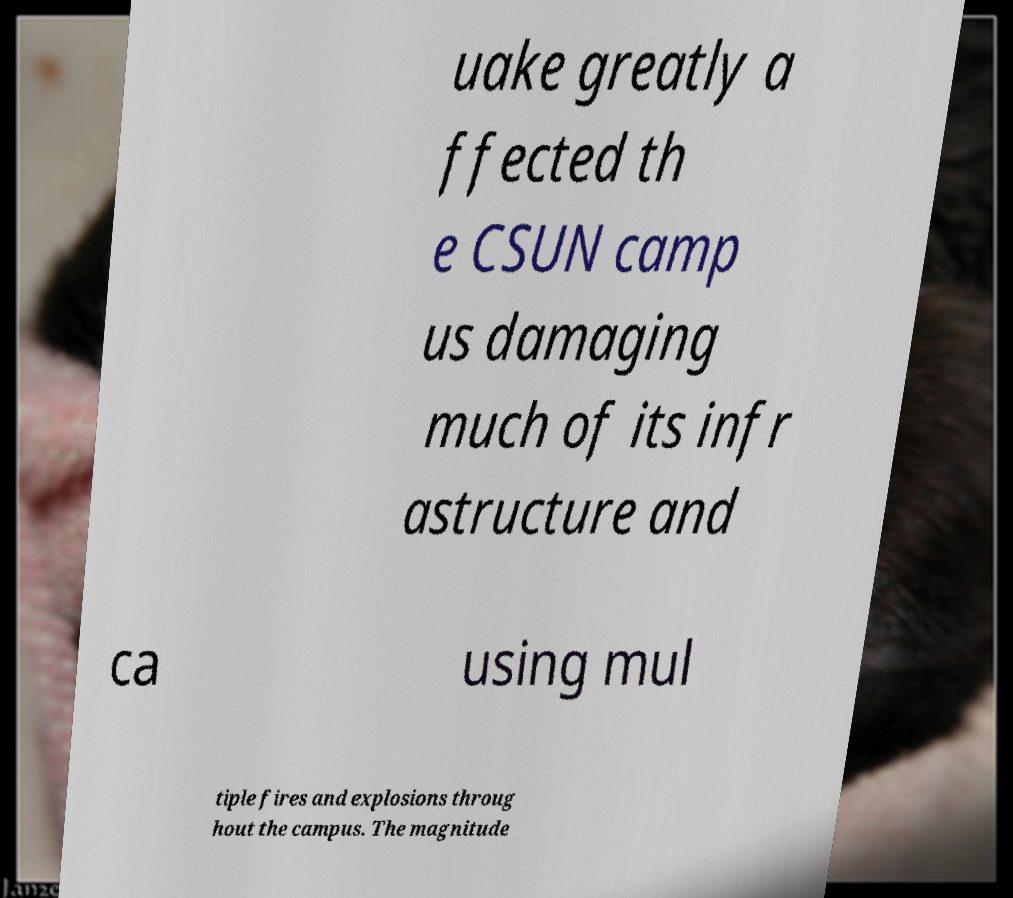Could you assist in decoding the text presented in this image and type it out clearly? uake greatly a ffected th e CSUN camp us damaging much of its infr astructure and ca using mul tiple fires and explosions throug hout the campus. The magnitude 